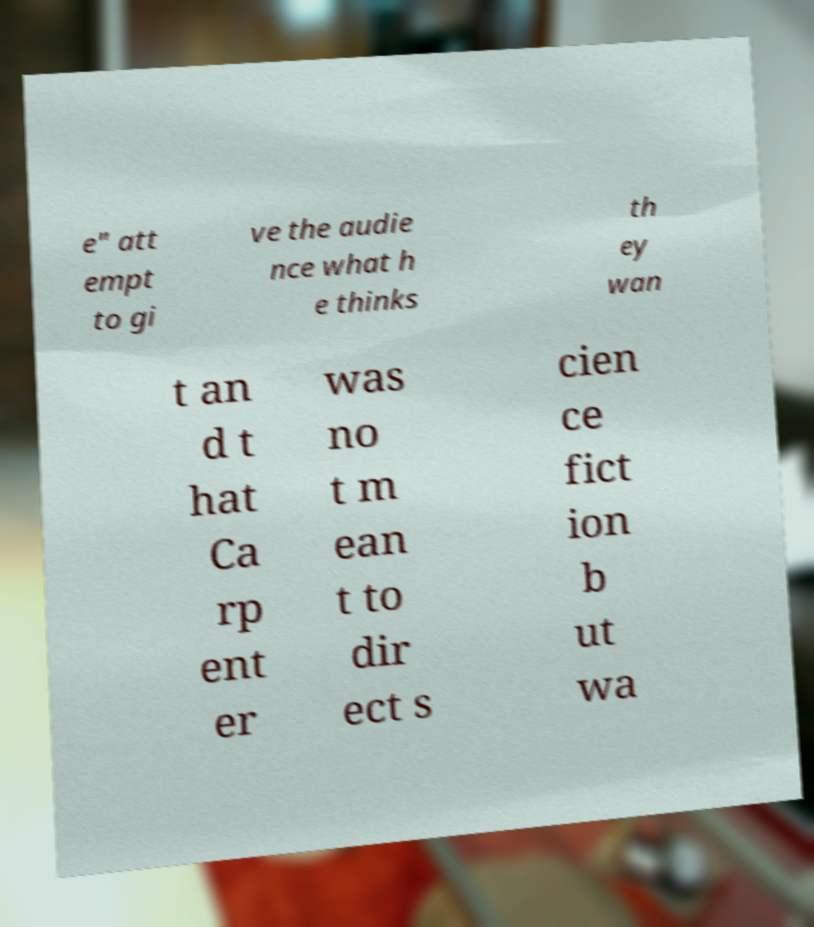Could you extract and type out the text from this image? e" att empt to gi ve the audie nce what h e thinks th ey wan t an d t hat Ca rp ent er was no t m ean t to dir ect s cien ce fict ion b ut wa 